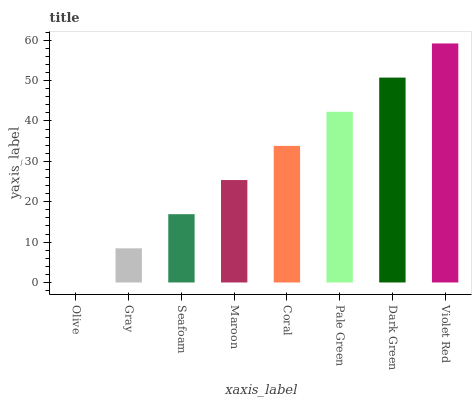Is Olive the minimum?
Answer yes or no. Yes. Is Violet Red the maximum?
Answer yes or no. Yes. Is Gray the minimum?
Answer yes or no. No. Is Gray the maximum?
Answer yes or no. No. Is Gray greater than Olive?
Answer yes or no. Yes. Is Olive less than Gray?
Answer yes or no. Yes. Is Olive greater than Gray?
Answer yes or no. No. Is Gray less than Olive?
Answer yes or no. No. Is Coral the high median?
Answer yes or no. Yes. Is Maroon the low median?
Answer yes or no. Yes. Is Seafoam the high median?
Answer yes or no. No. Is Olive the low median?
Answer yes or no. No. 